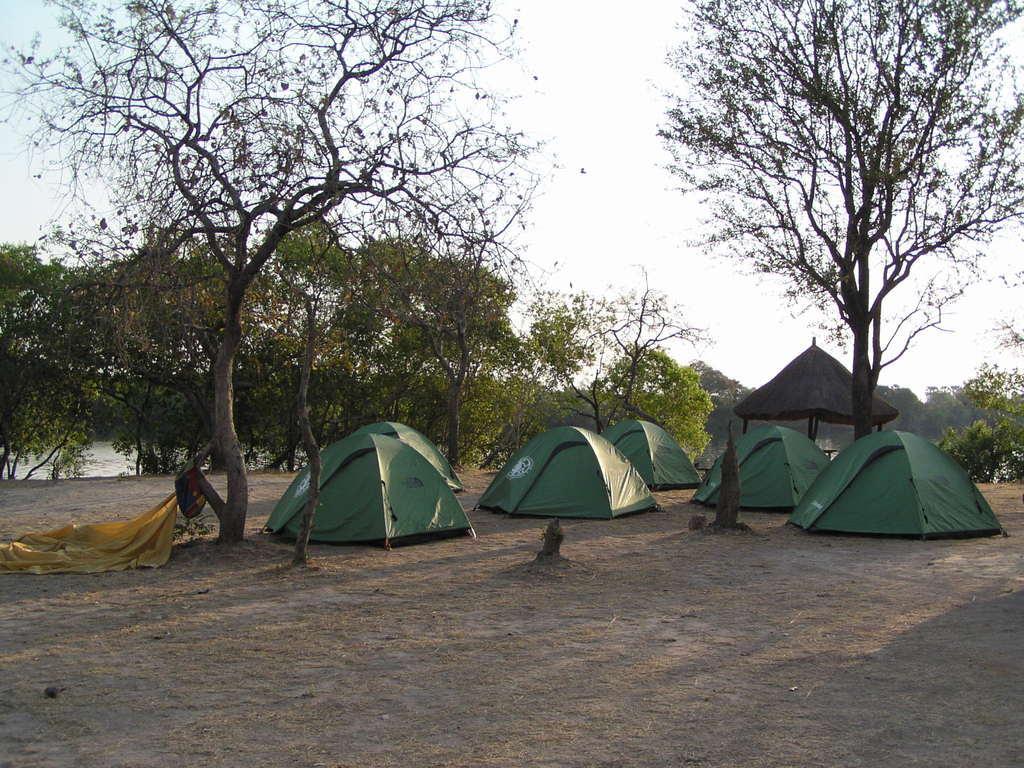Describe this image in one or two sentences. In the image we can see there are tents, trees and the sky. We can see the water and the pole hut. 